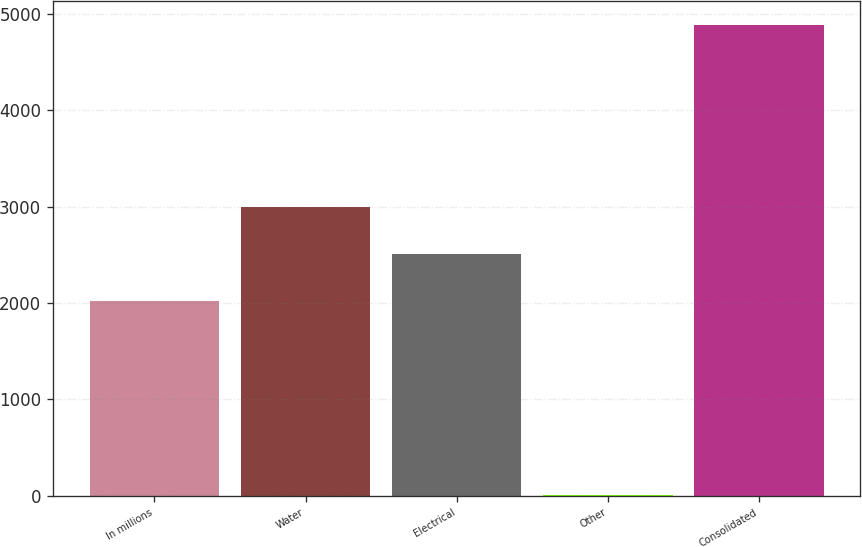Convert chart to OTSL. <chart><loc_0><loc_0><loc_500><loc_500><bar_chart><fcel>In millions<fcel>Water<fcel>Electrical<fcel>Other<fcel>Consolidated<nl><fcel>2016<fcel>2993.26<fcel>2504.63<fcel>3.7<fcel>4890<nl></chart> 